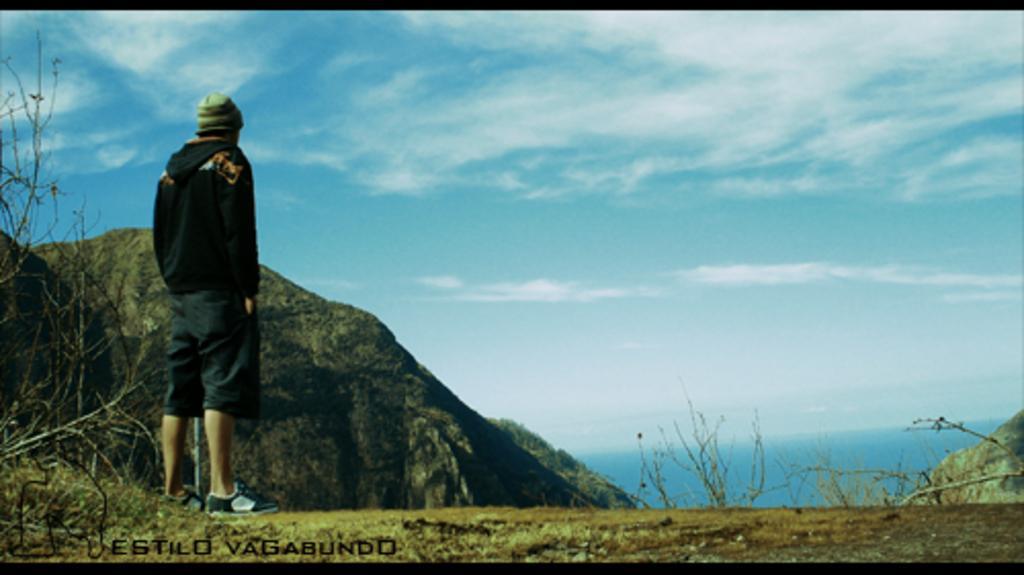How would you summarize this image in a sentence or two? In the background we can see a clear blue sky with clouds. Here we can see a person wearing a hoodie, cap, shoes and standing. These are dried plants. At the bottom left corner of the picture we can see water mark. 